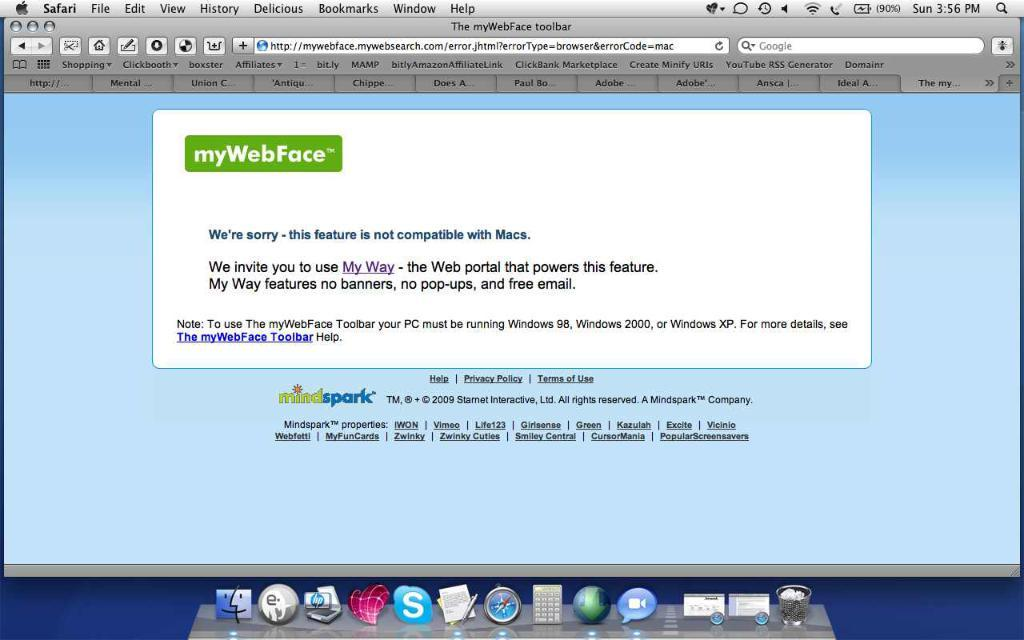<image>
Write a terse but informative summary of the picture. An error page that states the feature is not compatible. 